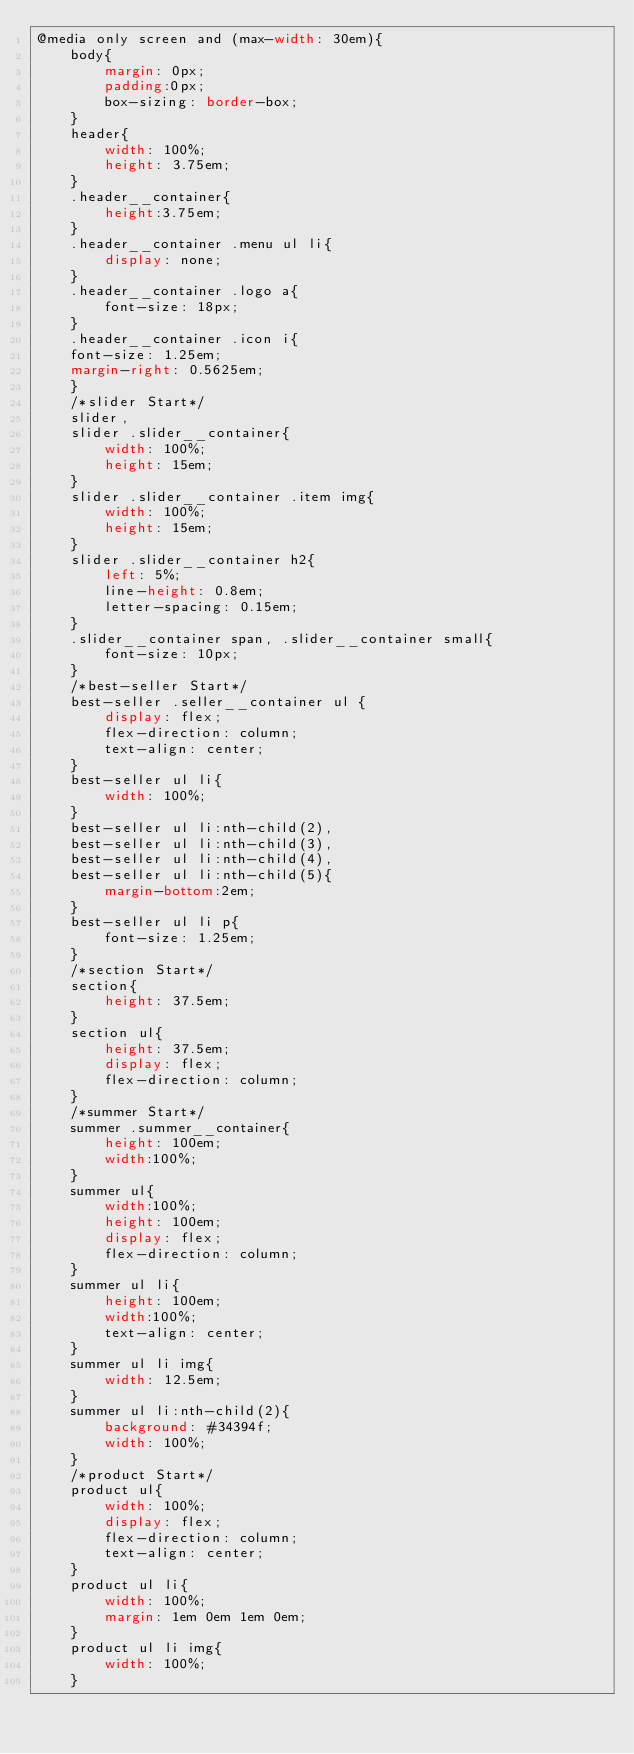<code> <loc_0><loc_0><loc_500><loc_500><_CSS_>@media only screen and (max-width: 30em){
	body{
		margin: 0px;
		padding:0px;
		box-sizing: border-box;
	}
	header{
		width: 100%;
		height: 3.75em;
	}
	.header__container{
		height:3.75em;	
	}
	.header__container .menu ul li{
		display: none;
	}
	.header__container .logo a{
		font-size: 18px;
	}
	.header__container .icon i{
	font-size: 1.25em;
	margin-right: 0.5625em;
	}
	/*slider Start*/
	slider,
	slider .slider__container{
	    width: 100%;
	    height: 15em;
	}
	slider .slider__container .item img{
		width: 100%;
		height: 15em;
	}
	slider .slider__container h2{
		left: 5%;
		line-height: 0.8em;
		letter-spacing: 0.15em;
	}
	.slider__container span, .slider__container small{
		font-size: 10px;
	}
	/*best-seller Start*/
	best-seller .seller__container ul {
	    display: flex;
	    flex-direction: column;
	    text-align: center;
	}
	best-seller ul li{
		width: 100%;
	}
	best-seller ul li:nth-child(2),
	best-seller ul li:nth-child(3),
	best-seller ul li:nth-child(4),
	best-seller ul li:nth-child(5){
		margin-bottom:2em;	
	}
	best-seller ul li p{
		font-size: 1.25em;
	}
	/*section Start*/
	section{
		height: 37.5em;
	}
	section ul{
		height: 37.5em;
		display: flex;
		flex-direction: column;
	}
	/*summer Start*/
	summer .summer__container{
		height: 100em;
		width:100%;
	}
	summer ul{
		width:100%;
		height: 100em;
		display: flex;
		flex-direction: column;
	}
	summer ul li{
		height: 100em;
		width:100%;
		text-align: center;
	}
	summer ul li img{
		width: 12.5em;
	}
	summer ul li:nth-child(2){
		background: #34394f;
		width: 100%;
	}
	/*product Start*/
	product ul{
		width: 100%;
		display: flex;
		flex-direction: column;
		text-align: center;
	}
	product ul li{
		width: 100%;
		margin: 1em 0em 1em 0em;
	}
	product ul li img{
		width: 100%;
	}</code> 